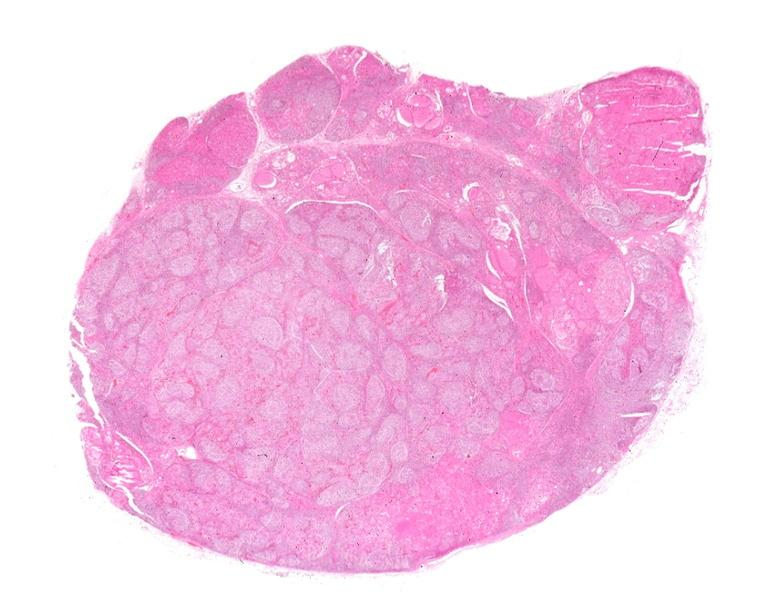where is this part in the figure?
Answer the question using a single word or phrase. Endocrine system 